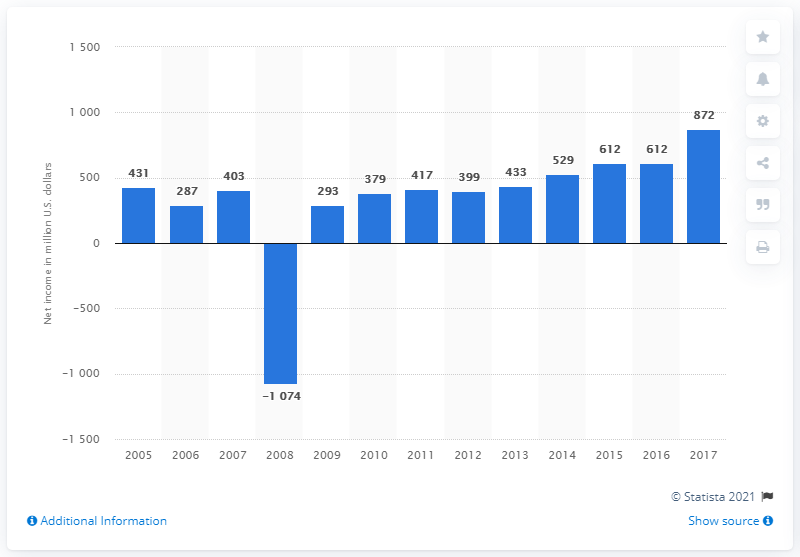Indicate a few pertinent items in this graphic. In 2017, the net income of the Wyndham Worldwide Corporation was $872 million in dollars. 